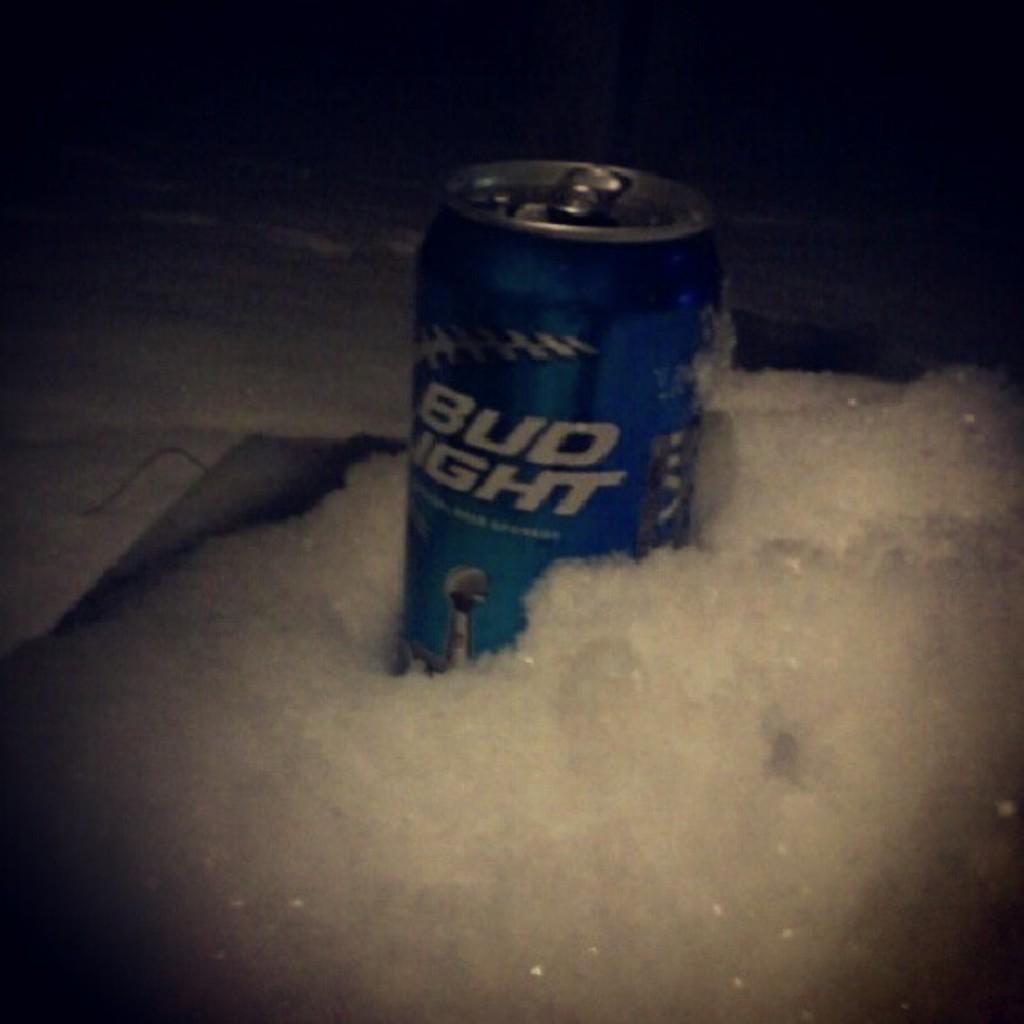<image>
Summarize the visual content of the image. An open can of Bud light sits in the snow. 